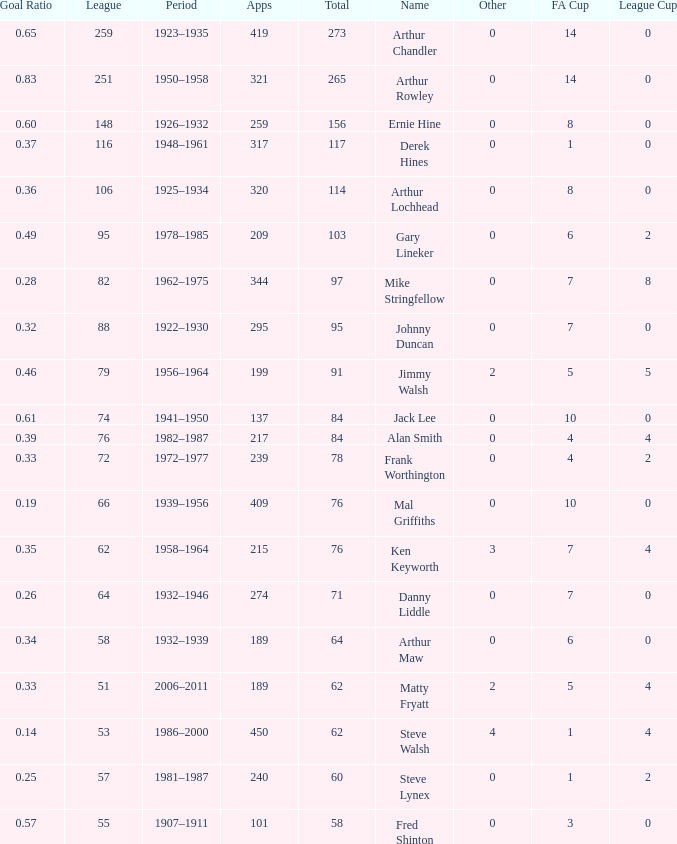What's the Highest Goal Ratio with a League of 88 and an FA Cup less than 7? None. 